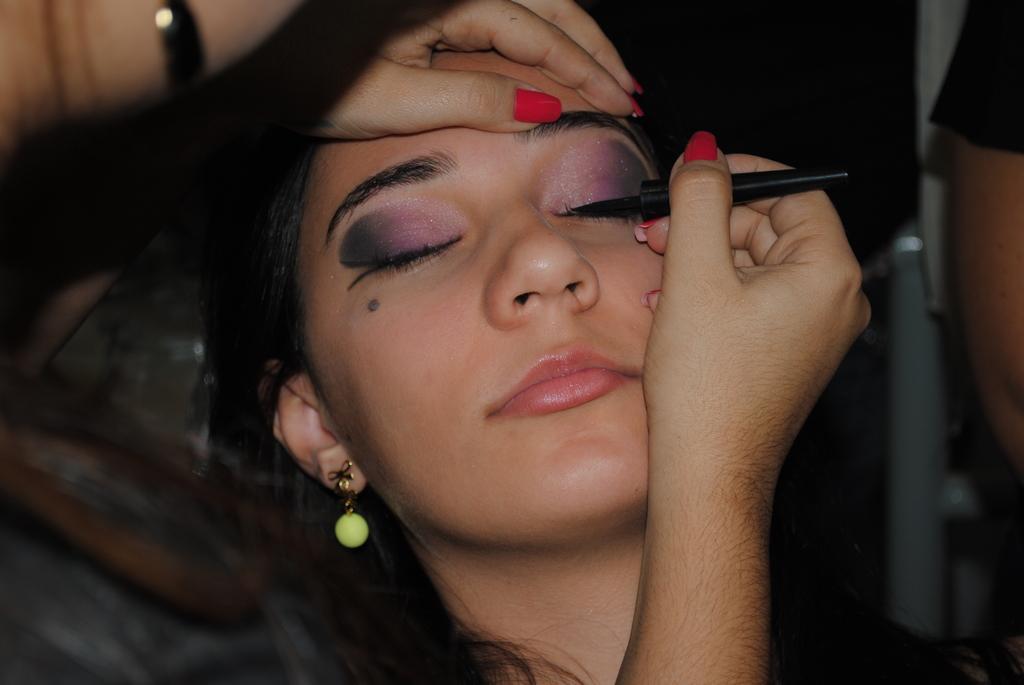Could you give a brief overview of what you see in this image? In this image there is a girl makeuping another girl, in the background it is blurred. 